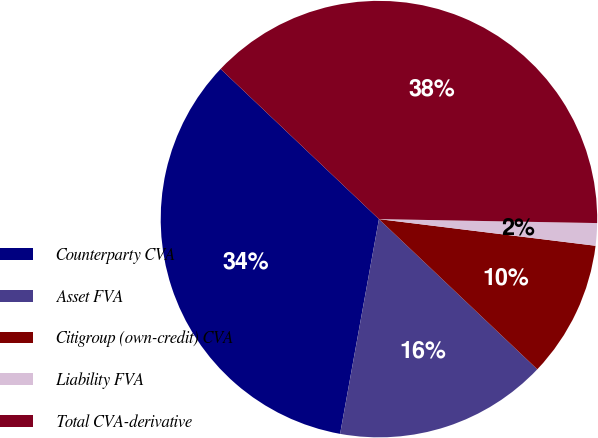Convert chart to OTSL. <chart><loc_0><loc_0><loc_500><loc_500><pie_chart><fcel>Counterparty CVA<fcel>Asset FVA<fcel>Citigroup (own-credit) CVA<fcel>Liability FVA<fcel>Total CVA-derivative<nl><fcel>34.23%<fcel>15.77%<fcel>10.13%<fcel>1.66%<fcel>38.21%<nl></chart> 